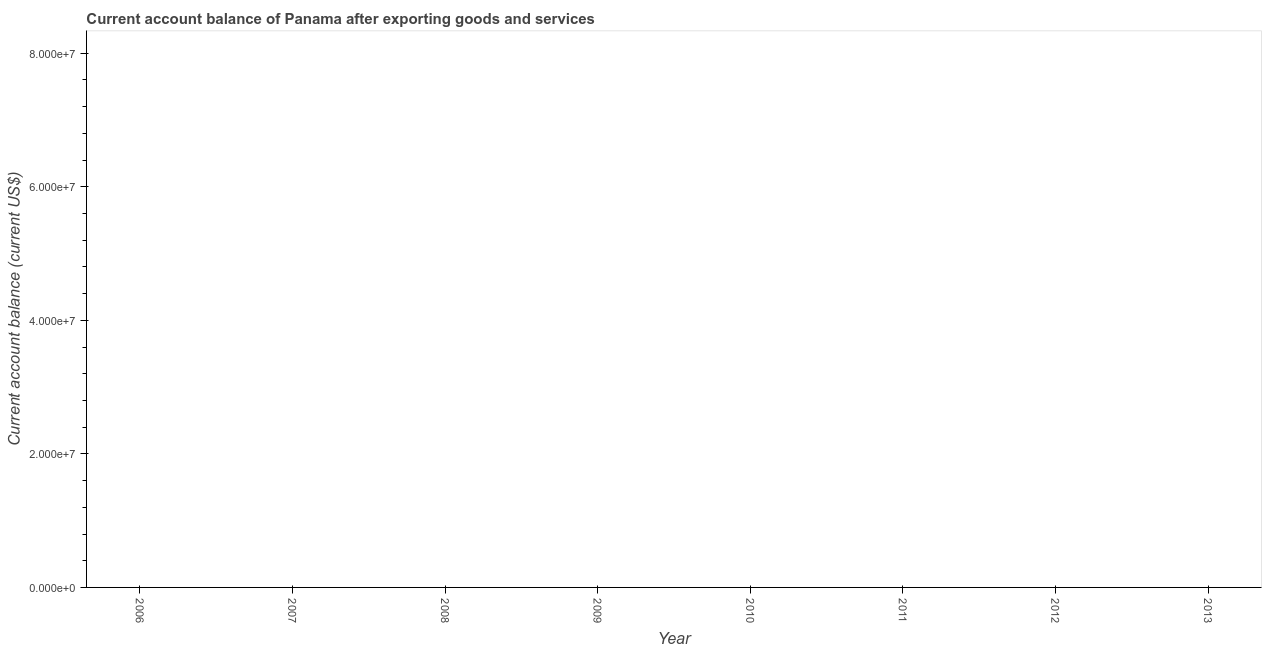What is the current account balance in 2008?
Your answer should be compact. 0. Across all years, what is the minimum current account balance?
Keep it short and to the point. 0. What is the sum of the current account balance?
Offer a terse response. 0. In how many years, is the current account balance greater than 12000000 US$?
Keep it short and to the point. 0. In how many years, is the current account balance greater than the average current account balance taken over all years?
Offer a very short reply. 0. Does the current account balance monotonically increase over the years?
Provide a succinct answer. No. How many years are there in the graph?
Offer a terse response. 8. What is the difference between two consecutive major ticks on the Y-axis?
Your answer should be very brief. 2.00e+07. Are the values on the major ticks of Y-axis written in scientific E-notation?
Provide a succinct answer. Yes. Does the graph contain grids?
Ensure brevity in your answer.  No. What is the title of the graph?
Provide a short and direct response. Current account balance of Panama after exporting goods and services. What is the label or title of the Y-axis?
Offer a very short reply. Current account balance (current US$). What is the Current account balance (current US$) in 2006?
Offer a very short reply. 0. What is the Current account balance (current US$) in 2007?
Offer a terse response. 0. What is the Current account balance (current US$) of 2008?
Provide a short and direct response. 0. What is the Current account balance (current US$) of 2009?
Provide a succinct answer. 0. What is the Current account balance (current US$) of 2010?
Keep it short and to the point. 0. What is the Current account balance (current US$) of 2011?
Offer a very short reply. 0. What is the Current account balance (current US$) of 2013?
Ensure brevity in your answer.  0. 